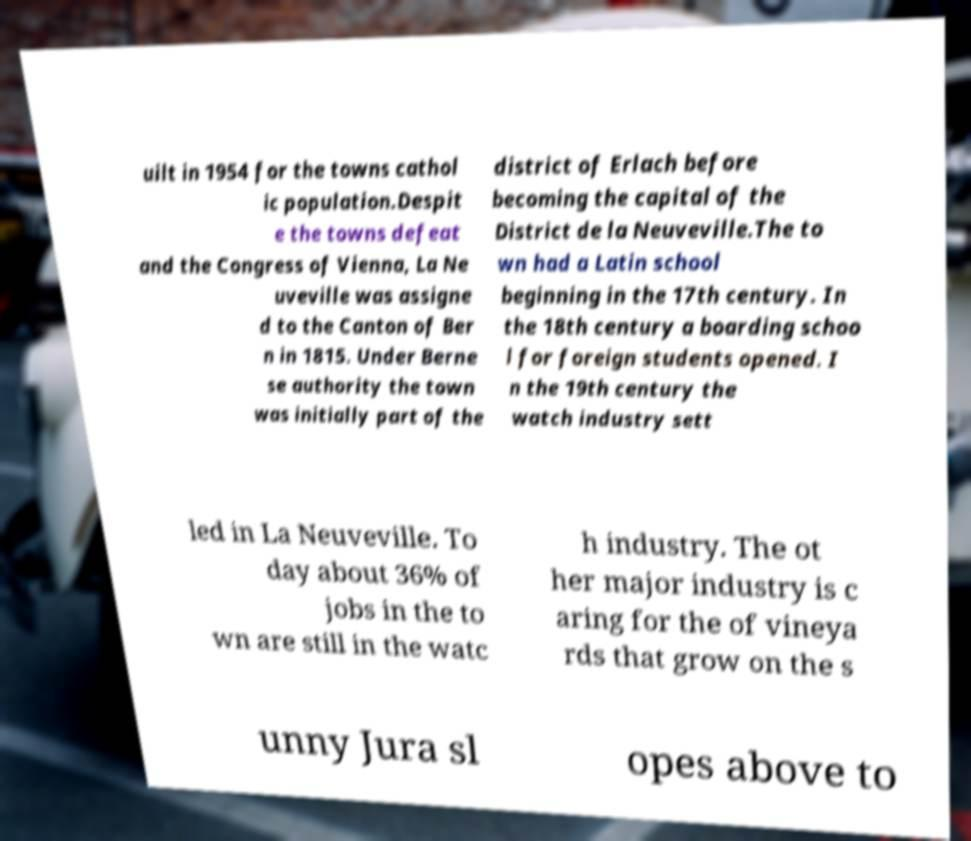Can you read and provide the text displayed in the image?This photo seems to have some interesting text. Can you extract and type it out for me? uilt in 1954 for the towns cathol ic population.Despit e the towns defeat and the Congress of Vienna, La Ne uveville was assigne d to the Canton of Ber n in 1815. Under Berne se authority the town was initially part of the district of Erlach before becoming the capital of the District de la Neuveville.The to wn had a Latin school beginning in the 17th century. In the 18th century a boarding schoo l for foreign students opened. I n the 19th century the watch industry sett led in La Neuveville. To day about 36% of jobs in the to wn are still in the watc h industry. The ot her major industry is c aring for the of vineya rds that grow on the s unny Jura sl opes above to 